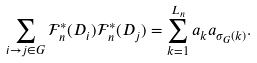<formula> <loc_0><loc_0><loc_500><loc_500>\sum _ { i \to j \in G } \mathcal { F } _ { n } ^ { \ast } ( D _ { i } ) \mathcal { F } _ { n } ^ { \ast } ( D _ { j } ) = \sum _ { k = 1 } ^ { L _ { n } } a _ { k } a _ { \sigma _ { G } ( k ) } .</formula> 